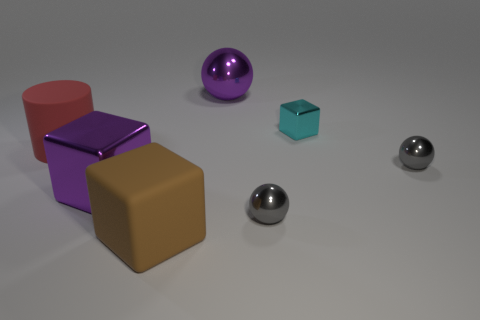Subtract all tiny cyan shiny cubes. How many cubes are left? 2 Add 1 cyan metal cubes. How many objects exist? 8 Subtract 1 cylinders. How many cylinders are left? 0 Subtract all purple blocks. Subtract all green balls. How many blocks are left? 2 Subtract all green cylinders. How many gray balls are left? 2 Subtract all purple matte cubes. Subtract all small metal spheres. How many objects are left? 5 Add 2 small gray shiny things. How many small gray shiny things are left? 4 Add 7 cyan rubber balls. How many cyan rubber balls exist? 7 Subtract all purple cubes. How many cubes are left? 2 Subtract 2 gray balls. How many objects are left? 5 